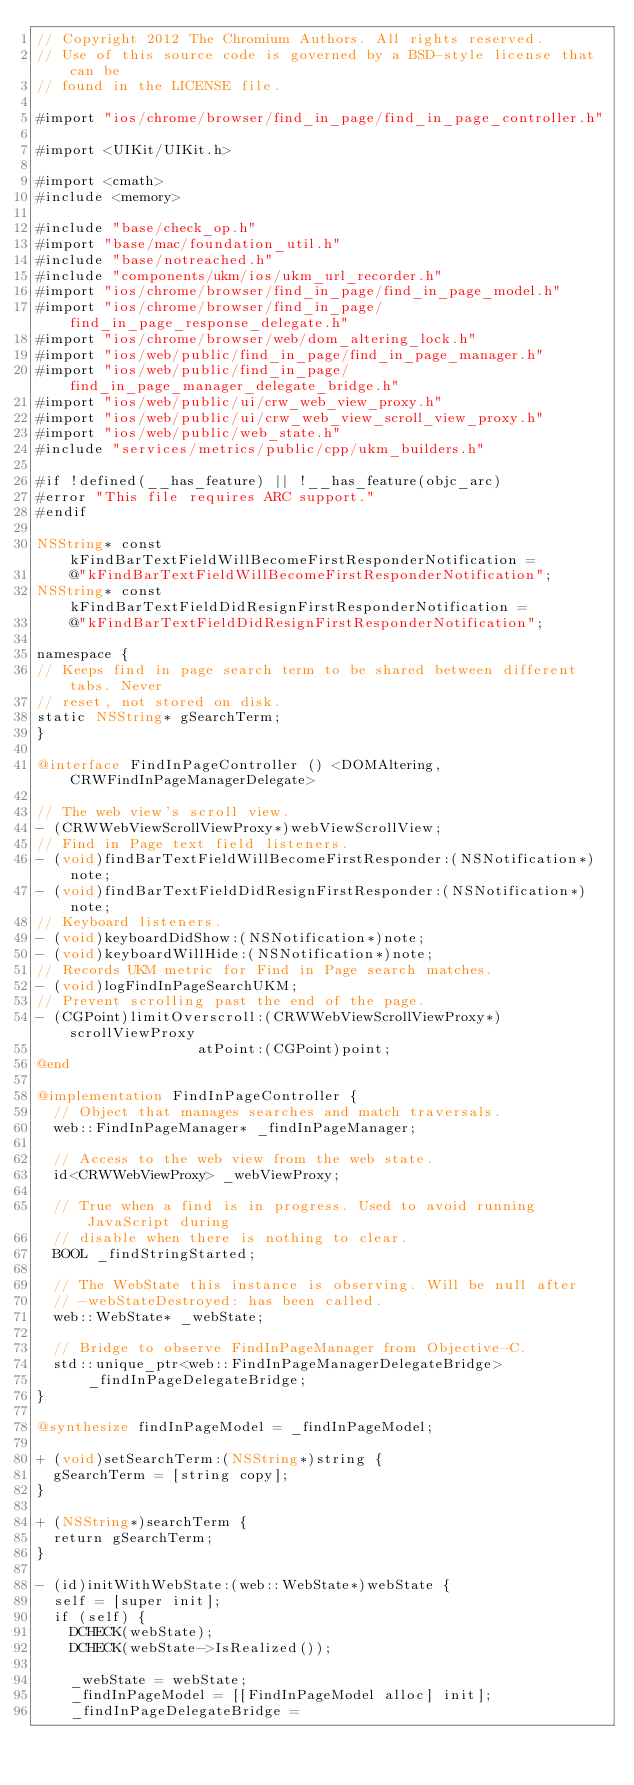Convert code to text. <code><loc_0><loc_0><loc_500><loc_500><_ObjectiveC_>// Copyright 2012 The Chromium Authors. All rights reserved.
// Use of this source code is governed by a BSD-style license that can be
// found in the LICENSE file.

#import "ios/chrome/browser/find_in_page/find_in_page_controller.h"

#import <UIKit/UIKit.h>

#import <cmath>
#include <memory>

#include "base/check_op.h"
#import "base/mac/foundation_util.h"
#include "base/notreached.h"
#include "components/ukm/ios/ukm_url_recorder.h"
#import "ios/chrome/browser/find_in_page/find_in_page_model.h"
#import "ios/chrome/browser/find_in_page/find_in_page_response_delegate.h"
#import "ios/chrome/browser/web/dom_altering_lock.h"
#import "ios/web/public/find_in_page/find_in_page_manager.h"
#import "ios/web/public/find_in_page/find_in_page_manager_delegate_bridge.h"
#import "ios/web/public/ui/crw_web_view_proxy.h"
#import "ios/web/public/ui/crw_web_view_scroll_view_proxy.h"
#import "ios/web/public/web_state.h"
#include "services/metrics/public/cpp/ukm_builders.h"

#if !defined(__has_feature) || !__has_feature(objc_arc)
#error "This file requires ARC support."
#endif

NSString* const kFindBarTextFieldWillBecomeFirstResponderNotification =
    @"kFindBarTextFieldWillBecomeFirstResponderNotification";
NSString* const kFindBarTextFieldDidResignFirstResponderNotification =
    @"kFindBarTextFieldDidResignFirstResponderNotification";

namespace {
// Keeps find in page search term to be shared between different tabs. Never
// reset, not stored on disk.
static NSString* gSearchTerm;
}

@interface FindInPageController () <DOMAltering, CRWFindInPageManagerDelegate>

// The web view's scroll view.
- (CRWWebViewScrollViewProxy*)webViewScrollView;
// Find in Page text field listeners.
- (void)findBarTextFieldWillBecomeFirstResponder:(NSNotification*)note;
- (void)findBarTextFieldDidResignFirstResponder:(NSNotification*)note;
// Keyboard listeners.
- (void)keyboardDidShow:(NSNotification*)note;
- (void)keyboardWillHide:(NSNotification*)note;
// Records UKM metric for Find in Page search matches.
- (void)logFindInPageSearchUKM;
// Prevent scrolling past the end of the page.
- (CGPoint)limitOverscroll:(CRWWebViewScrollViewProxy*)scrollViewProxy
                   atPoint:(CGPoint)point;
@end

@implementation FindInPageController {
  // Object that manages searches and match traversals.
  web::FindInPageManager* _findInPageManager;

  // Access to the web view from the web state.
  id<CRWWebViewProxy> _webViewProxy;

  // True when a find is in progress. Used to avoid running JavaScript during
  // disable when there is nothing to clear.
  BOOL _findStringStarted;

  // The WebState this instance is observing. Will be null after
  // -webStateDestroyed: has been called.
  web::WebState* _webState;

  // Bridge to observe FindInPageManager from Objective-C.
  std::unique_ptr<web::FindInPageManagerDelegateBridge>
      _findInPageDelegateBridge;
}

@synthesize findInPageModel = _findInPageModel;

+ (void)setSearchTerm:(NSString*)string {
  gSearchTerm = [string copy];
}

+ (NSString*)searchTerm {
  return gSearchTerm;
}

- (id)initWithWebState:(web::WebState*)webState {
  self = [super init];
  if (self) {
    DCHECK(webState);
    DCHECK(webState->IsRealized());

    _webState = webState;
    _findInPageModel = [[FindInPageModel alloc] init];
    _findInPageDelegateBridge =</code> 